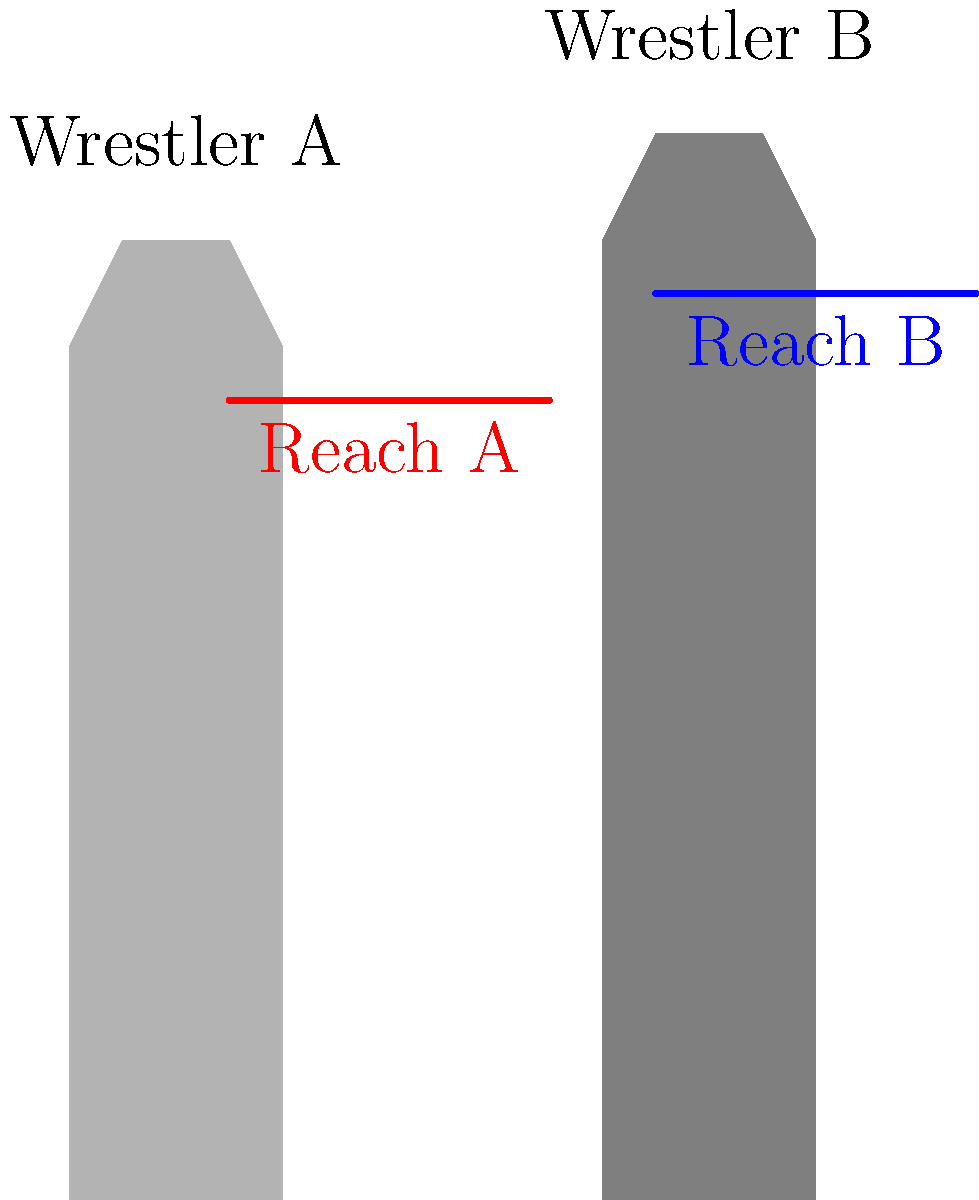Ladies and gentlemen! As we gear up for this epic showdown, let's analyze our competitors! Based on the silhouettes and reach lines shown, which wrestler has the greater reach advantage compared to their height difference? Get ready to witness a clash of titans! Let's break this down, step by step, to determine who has the greater reach advantage:

1. Height difference:
   - Wrestler A's height: approximately 180 units
   - Wrestler B's height: approximately 200 units
   - Height difference: 200 - 180 = 20 units

2. Reach difference:
   - Wrestler A's reach: from 30 to 90 = 60 units
   - Wrestler B's reach: from 110 to 170 = 60 units
   - Reach difference: 60 - 60 = 0 units

3. Comparing reach advantage to height difference:
   - Despite the height difference of 20 units, both wrestlers have the same reach (60 units).
   - This means Wrestler A has a greater reach advantage relative to their height.

4. Proportional analysis:
   - Wrestler A's reach is about $\frac{60}{180} \approx 33.3\%$ of their height
   - Wrestler B's reach is about $\frac{60}{200} = 30\%$ of their height

Therefore, Wrestler A has a proportionally longer reach for their height, giving them a greater reach advantage compared to the height difference between the two wrestlers.
Answer: Wrestler A 